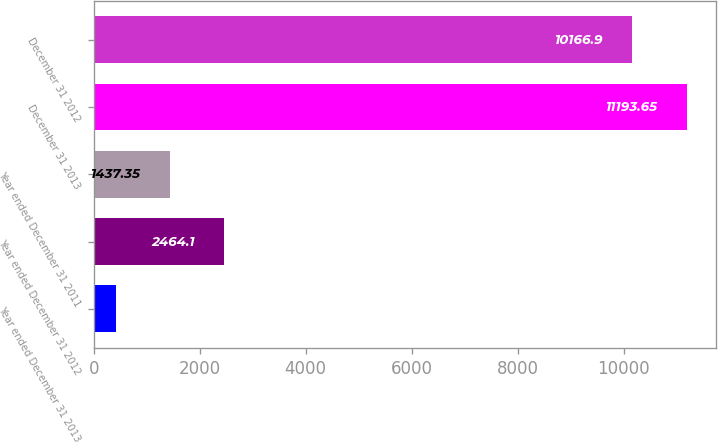Convert chart to OTSL. <chart><loc_0><loc_0><loc_500><loc_500><bar_chart><fcel>Year ended December 31 2013<fcel>Year ended December 31 2012<fcel>Year ended December 31 2011<fcel>December 31 2013<fcel>December 31 2012<nl><fcel>410.6<fcel>2464.1<fcel>1437.35<fcel>11193.6<fcel>10166.9<nl></chart> 